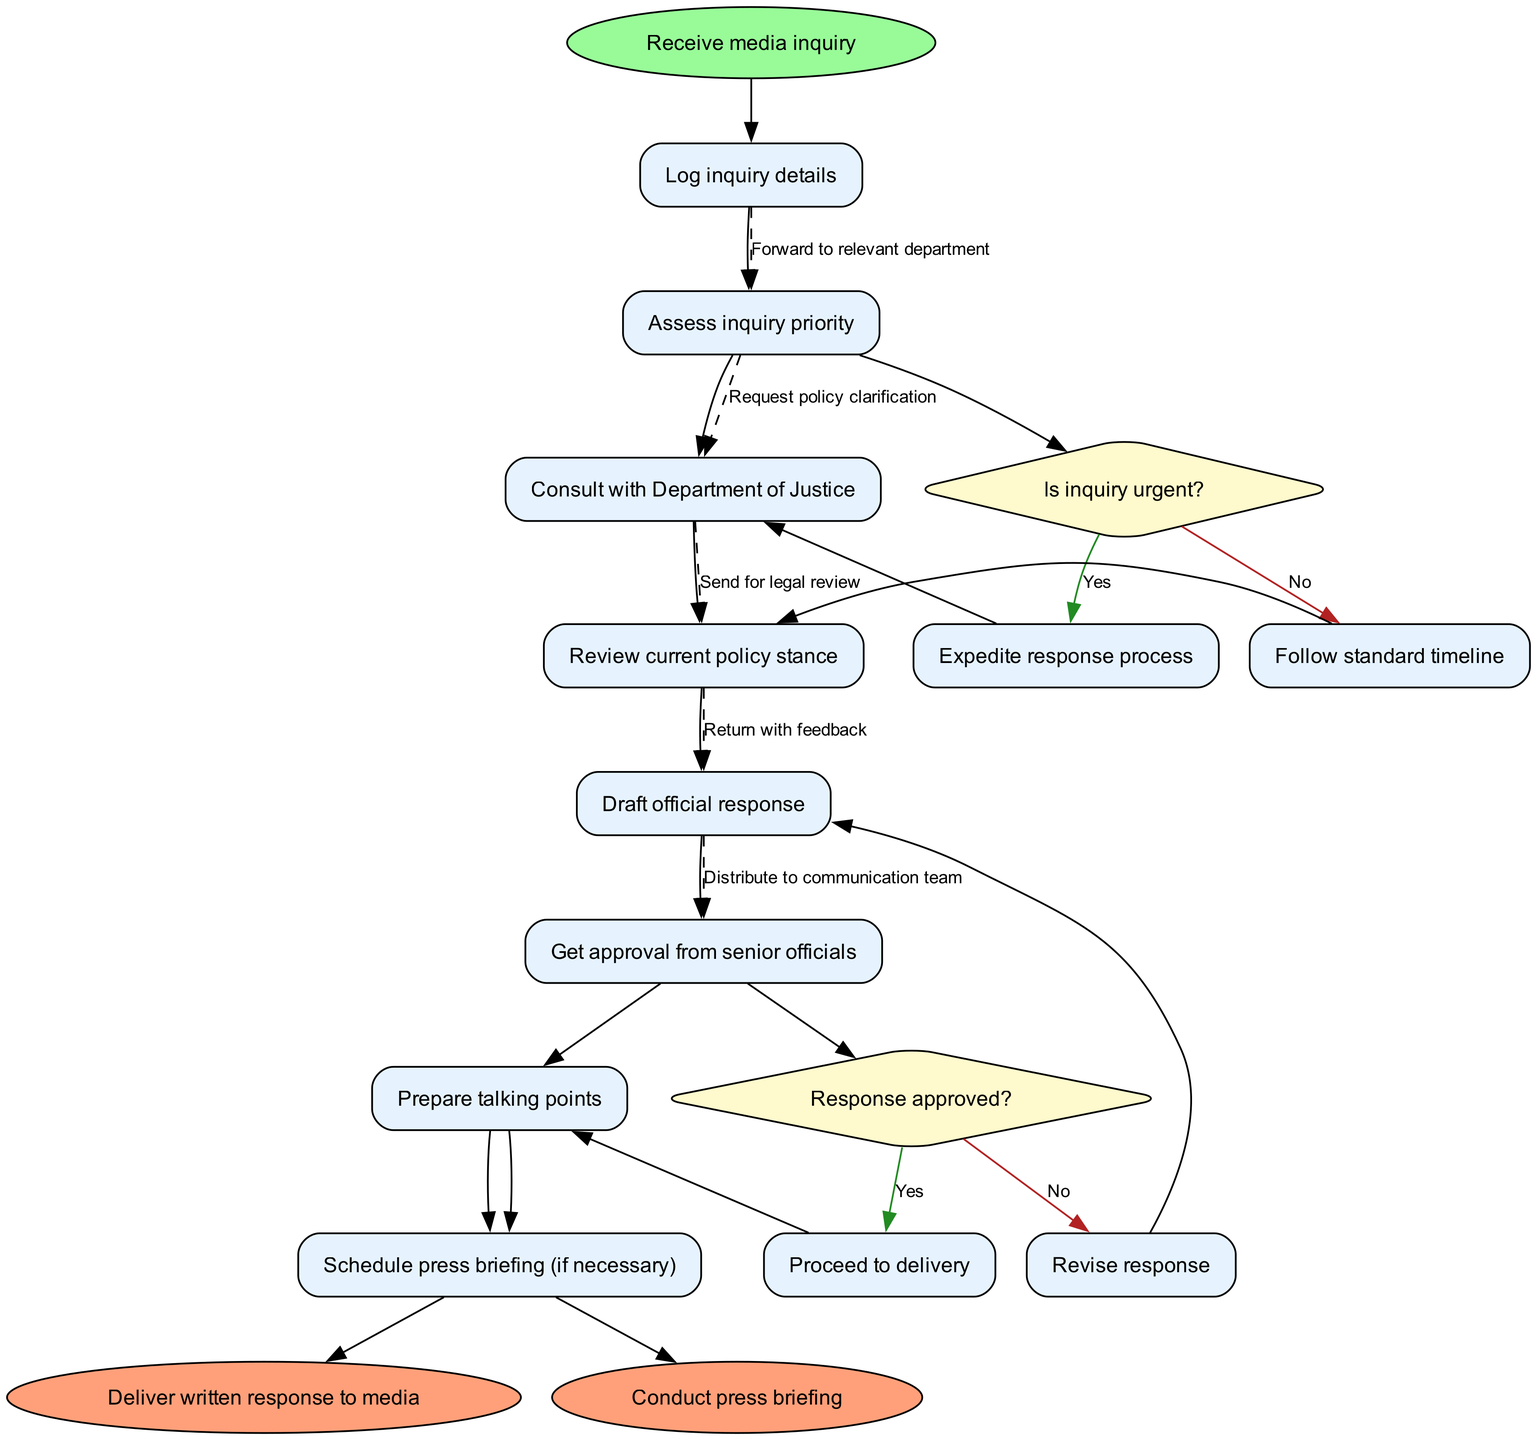What is the first activity after receiving a media inquiry? After the starting node, the next activity is to log the details of the inquiry. This follows immediately after the "Receive media inquiry" start node.
Answer: Log inquiry details How many activities are involved in the workflow? The diagram contains a total of eight activities through which the process flows from start to end. These include logging the inquiry, assessing priority, consulting, reviewing, drafting, getting approval, preparing talking points, and scheduling if necessary.
Answer: Eight What decision follows the assessment of inquiry priority? Following the assessment of inquiry priority, the decision made is whether the inquiry is urgent or not. This is a key decision point that influences the workflow's subsequent actions.
Answer: Is inquiry urgent? What happens if the response is not approved? If the response is not approved, the next step is to revise the response based on the feedback received. This demonstrates the iterative nature of the process, ensuring that the response meets the required standards before delivery.
Answer: Revise response What are the end nodes of the activity diagram? The workflow concludes with two end nodes: delivering a written response to the media and conducting a press briefing if deemed necessary. These represent the final steps in responding to the media inquiry.
Answer: Deliver written response to media, Conduct press briefing How many decisions are present in the diagram? There are two decisions present in the diagram. They ask whether the inquiry is urgent and whether the response is approved, thereby shaping how the process adapts to different scenarios.
Answer: Two What is the relationship between the "Draft official response" and the "Get approval from senior officials"? The "Draft official response" directly precedes the "Get approval from senior officials," indicating that the drafting of a response is a necessary step before any approval can be sought in the workflow process.
Answer: Directly precedes What is the purpose of preparing talking points? Preparing talking points is crucial as it helps to summarize key messages or points that need to be communicated during responses or briefings, ensuring clarity and consistency across communication efforts.
Answer: Summarize key messages 